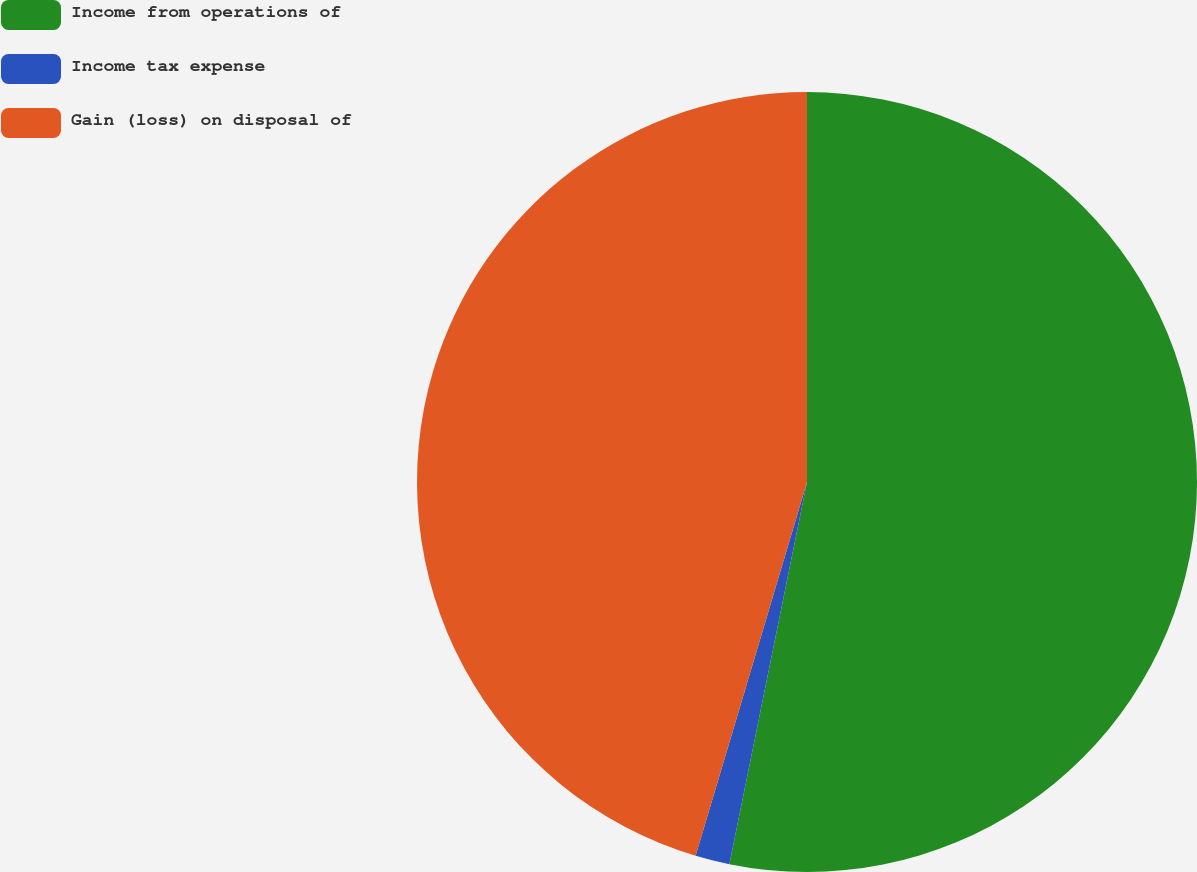<chart> <loc_0><loc_0><loc_500><loc_500><pie_chart><fcel>Income from operations of<fcel>Income tax expense<fcel>Gain (loss) on disposal of<nl><fcel>53.19%<fcel>1.42%<fcel>45.39%<nl></chart> 